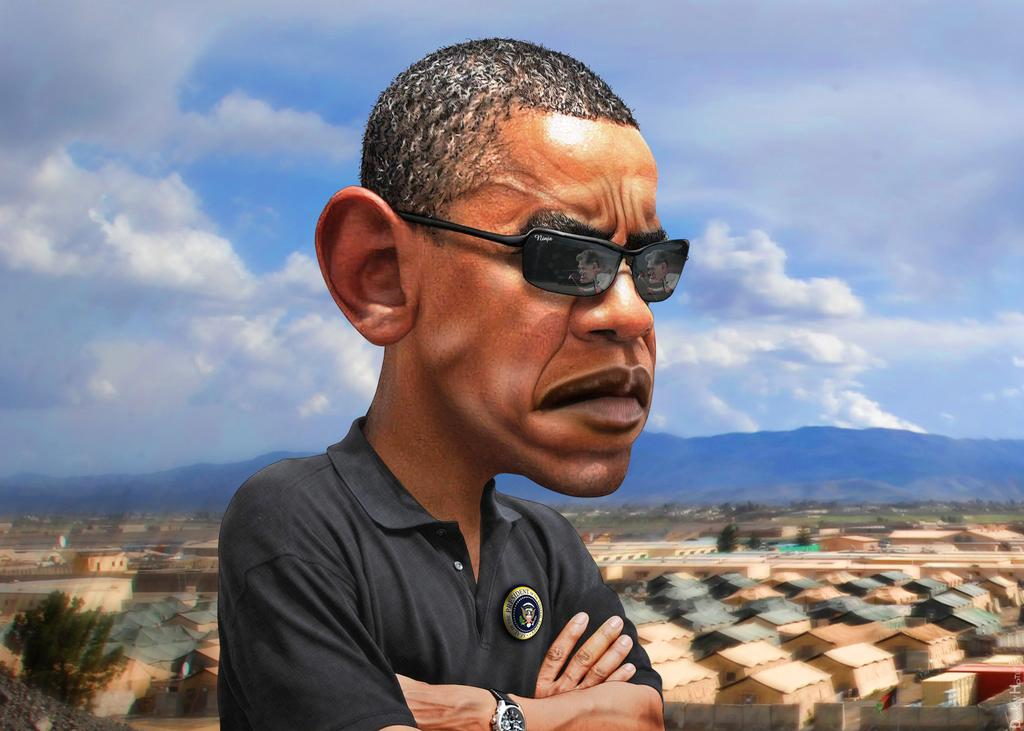What type of image is being described? The image is graphical in nature. Can you describe the person in the image? There is a person standing in the image. What can be seen behind the person? There are trees behind the person. What other elements are visible in the background? There are buildings and hills visible in the background. What is present at the top of the image? There are clouds and the sky visible at the top of the image. What type of garden can be seen in the image? There is no garden present in the image; it features a person standing in front of trees, buildings, and hills. Is the image a print or a digital representation? The facts provided do not specify whether the image is a print or a digital representation. 